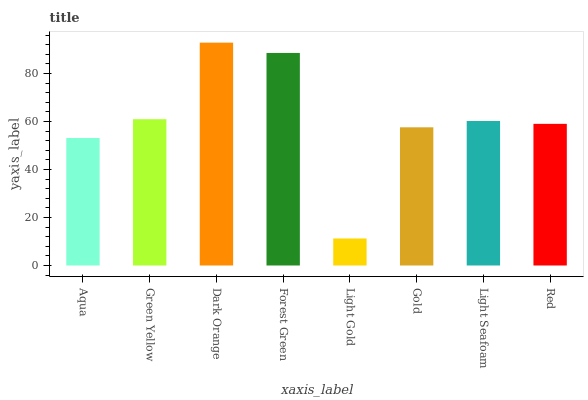Is Light Gold the minimum?
Answer yes or no. Yes. Is Dark Orange the maximum?
Answer yes or no. Yes. Is Green Yellow the minimum?
Answer yes or no. No. Is Green Yellow the maximum?
Answer yes or no. No. Is Green Yellow greater than Aqua?
Answer yes or no. Yes. Is Aqua less than Green Yellow?
Answer yes or no. Yes. Is Aqua greater than Green Yellow?
Answer yes or no. No. Is Green Yellow less than Aqua?
Answer yes or no. No. Is Light Seafoam the high median?
Answer yes or no. Yes. Is Red the low median?
Answer yes or no. Yes. Is Gold the high median?
Answer yes or no. No. Is Green Yellow the low median?
Answer yes or no. No. 